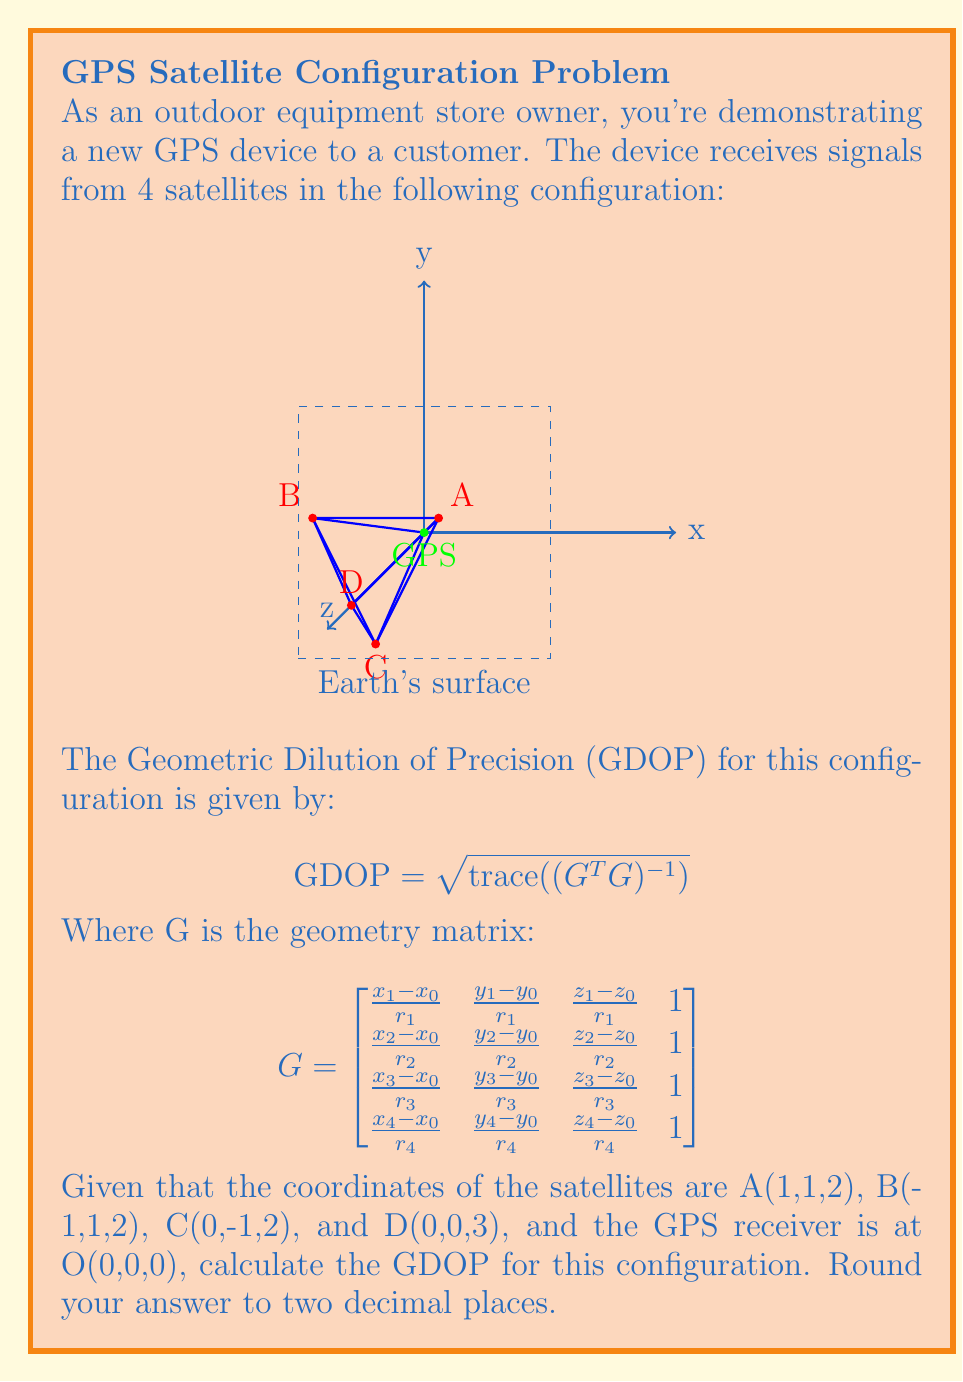Teach me how to tackle this problem. To solve this problem, we'll follow these steps:

1) First, we need to calculate the distances (r) from each satellite to the GPS receiver:

   $r_1 = \sqrt{1^2 + 1^2 + 2^2} = \sqrt{6}$
   $r_2 = \sqrt{(-1)^2 + 1^2 + 2^2} = \sqrt{6}$
   $r_3 = \sqrt{0^2 + (-1)^2 + 2^2} = \sqrt{5}$
   $r_4 = \sqrt{0^2 + 0^2 + 3^2} = 3$

2) Now we can construct the G matrix:

   $$ G = \begin{bmatrix}
   \frac{1}{\sqrt{6}} & \frac{1}{\sqrt{6}} & \frac{2}{\sqrt{6}} & 1 \\
   -\frac{1}{\sqrt{6}} & \frac{1}{\sqrt{6}} & \frac{2}{\sqrt{6}} & 1 \\
   0 & -\frac{1}{\sqrt{5}} & \frac{2}{\sqrt{5}} & 1 \\
   0 & 0 & 1 & 1
   \end{bmatrix} $$

3) Calculate $G^TG$:

   $$ G^TG = \begin{bmatrix}
   \frac{1}{3} & 0 & \frac{1}{3} & \frac{1}{\sqrt{6}} \\
   0 & \frac{3}{10} & \frac{1}{3\sqrt{5}} & 0 \\
   \frac{1}{3} & \frac{1}{3\sqrt{5}} & \frac{17}{15} & 1 \\
   \frac{1}{\sqrt{6}} & 0 & 1 & 4
   \end{bmatrix} $$

4) Calculate $(G^TG)^{-1}$:

   $$ (G^TG)^{-1} \approx \begin{bmatrix}
   3.6 & 0 & -0.9 & 0 \\
   0 & 3.33 & 0 & 0 \\
   -0.9 & 0 & 0.9 & -0.3 \\
   0 & 0 & -0.3 & 0.3
   \end{bmatrix} $$

5) Calculate the trace of $(G^TG)^{-1}$:

   $\text{trace}((G^TG)^{-1}) = 3.6 + 3.33 + 0.9 + 0.3 = 8.13$

6) Finally, calculate GDOP:

   $GDOP = \sqrt{8.13} \approx 2.85$

Rounding to two decimal places, we get 2.85.
Answer: 2.85 